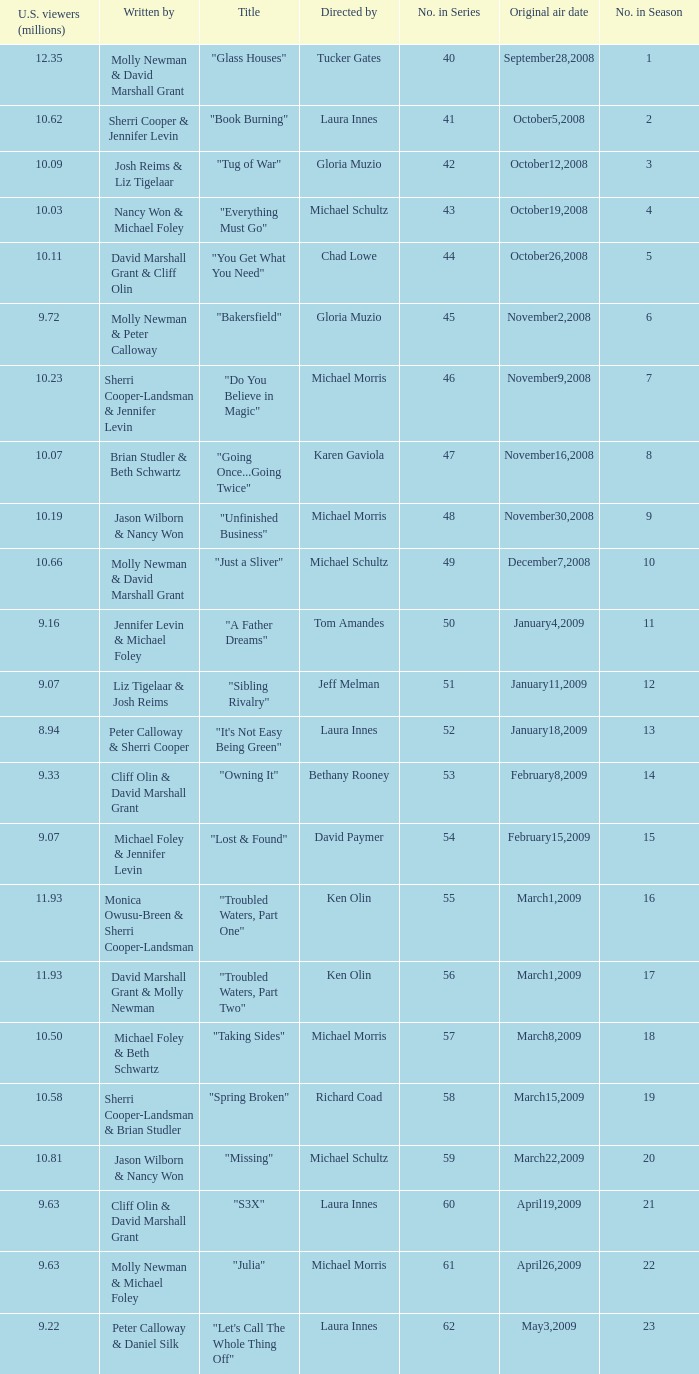What's the name of the episode seen by 9.63 millions of people in the US, whose director is Laura Innes? "S3X". 